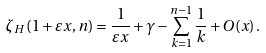<formula> <loc_0><loc_0><loc_500><loc_500>\zeta _ { H } \left ( 1 + \varepsilon x , n \right ) = \frac { 1 } { \varepsilon x } + \gamma - \sum _ { k = 1 } ^ { n - 1 } \frac { 1 } { k } + O ( x ) \, .</formula> 